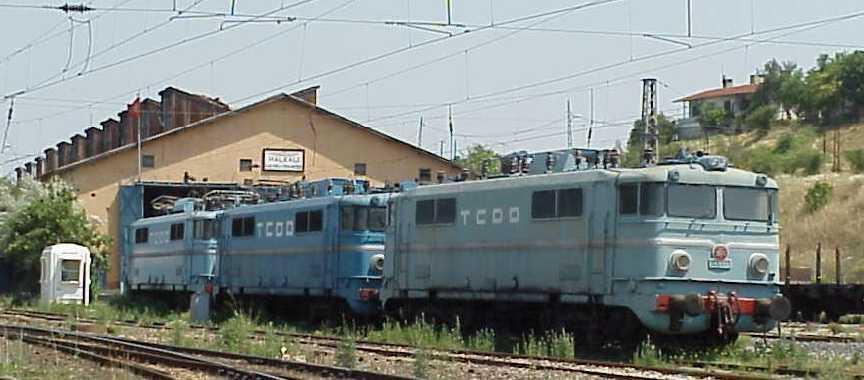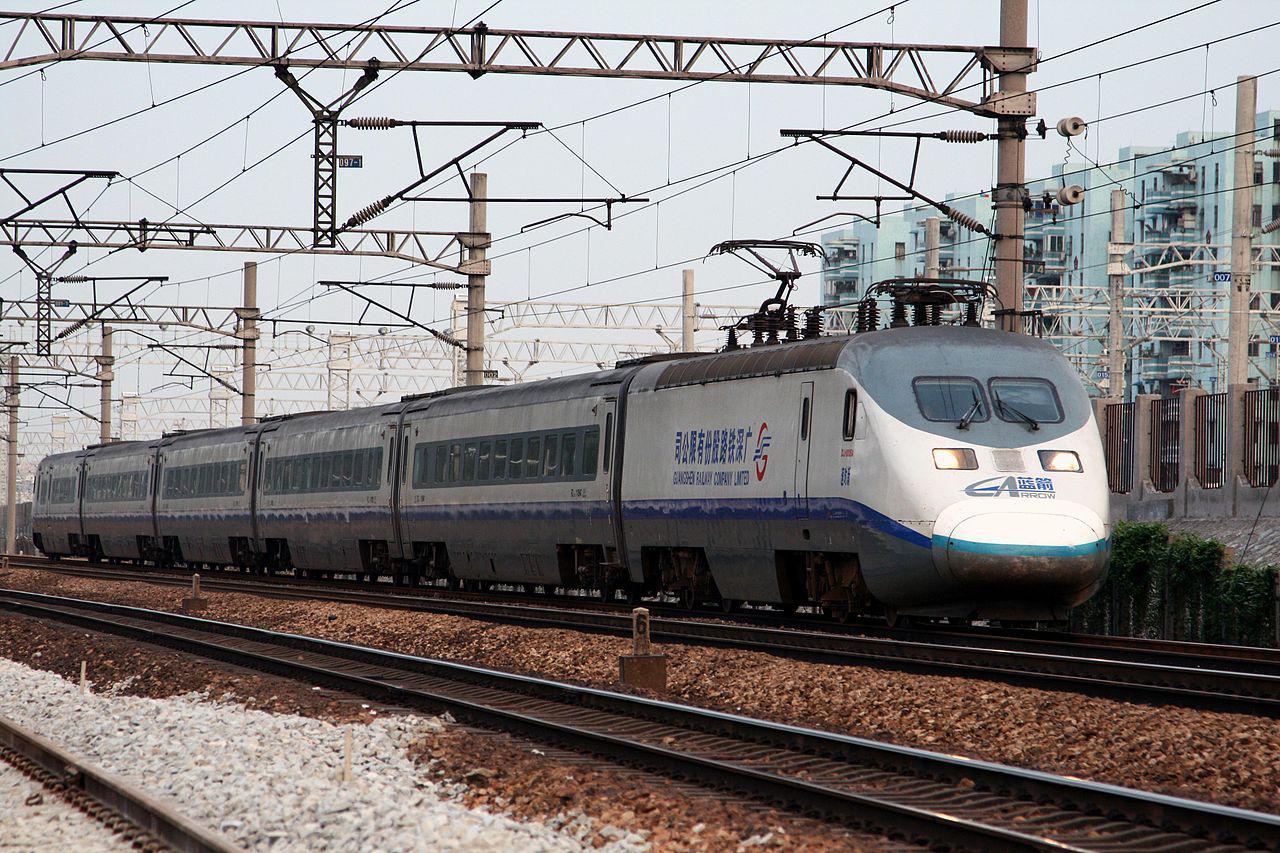The first image is the image on the left, the second image is the image on the right. Assess this claim about the two images: "One train contains the three colors red, white, and blue on the main body.". Correct or not? Answer yes or no. No. The first image is the image on the left, the second image is the image on the right. Given the left and right images, does the statement "Both images have trains facing towards the right." hold true? Answer yes or no. Yes. 